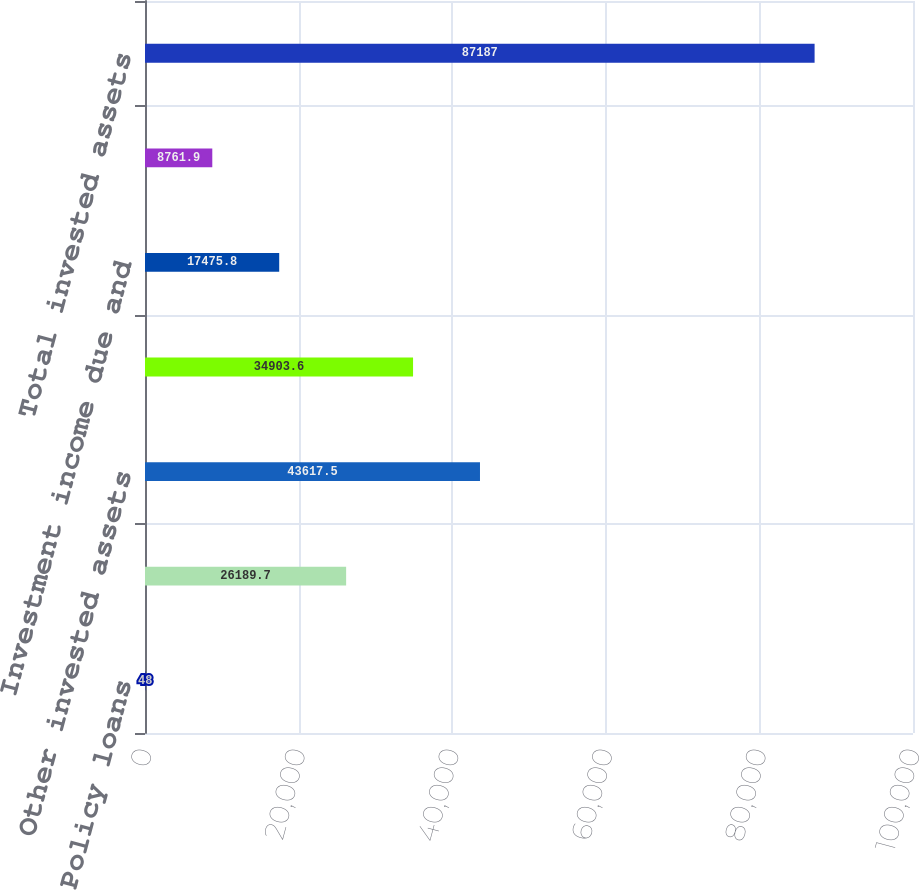Convert chart. <chart><loc_0><loc_0><loc_500><loc_500><bar_chart><fcel>Policy loans<fcel>Collateral and guaranteed<fcel>Other invested assets<fcel>Short-term investments at cost<fcel>Investment income due and<fcel>Real estate net of accumulated<fcel>Total invested assets<nl><fcel>48<fcel>26189.7<fcel>43617.5<fcel>34903.6<fcel>17475.8<fcel>8761.9<fcel>87187<nl></chart> 